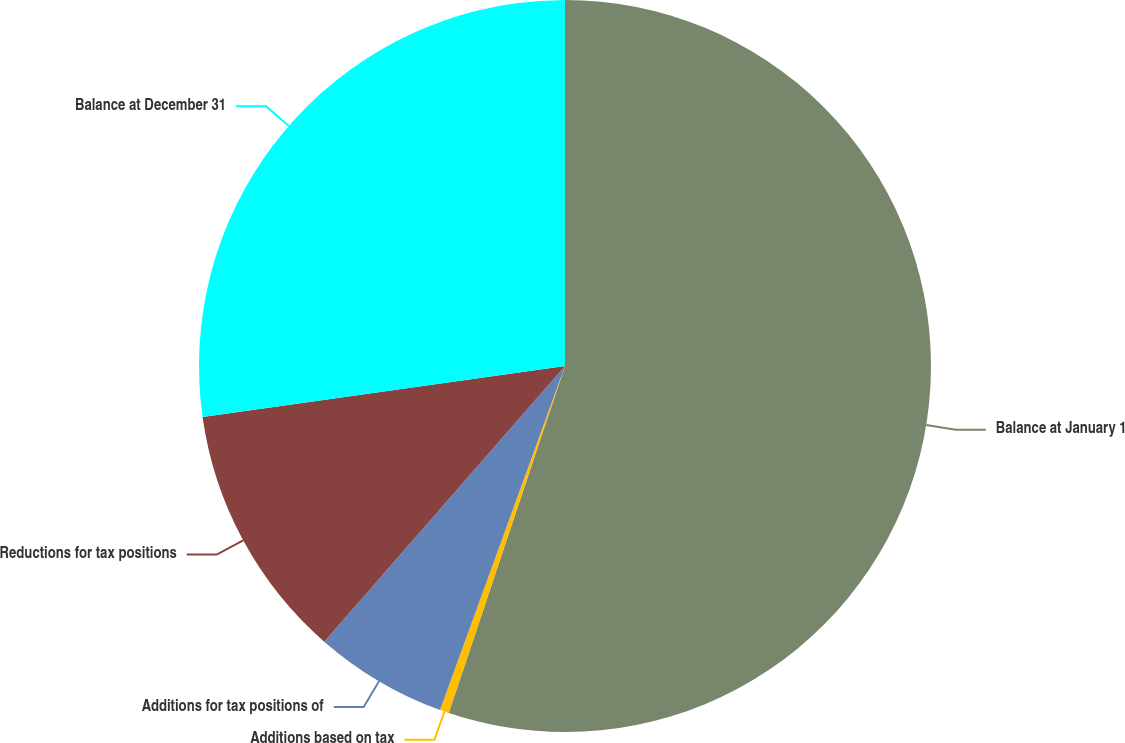Convert chart to OTSL. <chart><loc_0><loc_0><loc_500><loc_500><pie_chart><fcel>Balance at January 1<fcel>Additions based on tax<fcel>Additions for tax positions of<fcel>Reductions for tax positions<fcel>Balance at December 31<nl><fcel>55.14%<fcel>0.4%<fcel>5.88%<fcel>11.35%<fcel>27.22%<nl></chart> 